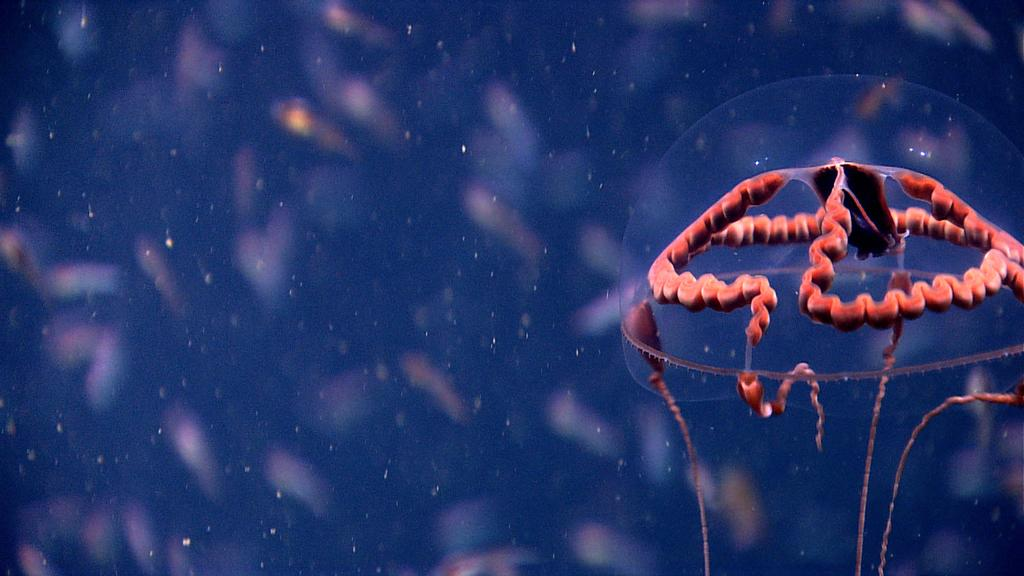What is the main subject of the image? There is a jellyfish in the image. Can you describe the background of the image? The background of the image is blurred. What type of cattle can be seen grazing in the background of the image? There is no cattle present in the image; it features a jellyfish with a blurred background. What musical instrument is being played by the jellyfish in the image? There is no musical instrument present in the image, as it features a jellyfish in a blurred background. 